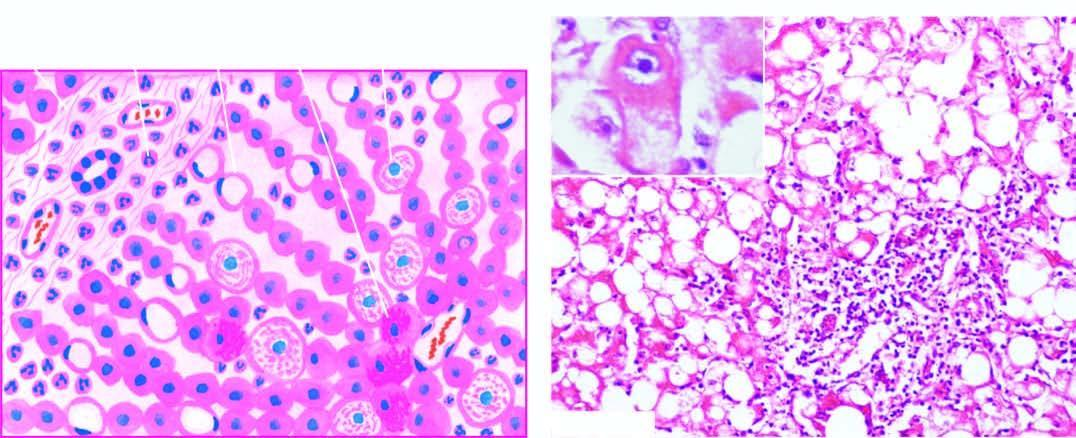do liver cells show ballooning degeneration and necrosis with some containing mallory 's hyalin inbox?
Answer the question using a single word or phrase. Yes 